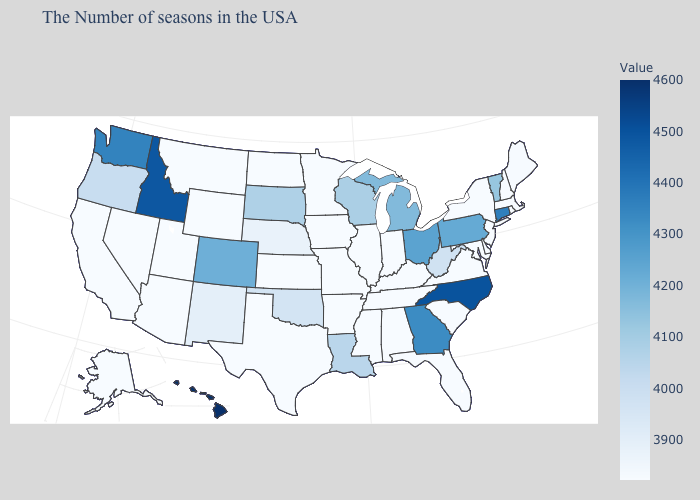Which states have the highest value in the USA?
Concise answer only. Hawaii. Which states have the highest value in the USA?
Keep it brief. Hawaii. Among the states that border Iowa , does Illinois have the lowest value?
Keep it brief. Yes. Does Ohio have the highest value in the MidWest?
Concise answer only. Yes. 